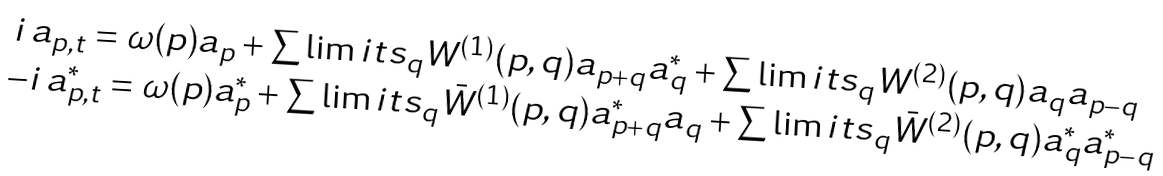<formula> <loc_0><loc_0><loc_500><loc_500>\begin{array} { l } \, i \, a _ { p , t } = \omega ( p ) a _ { p } + \sum \lim i t s _ { q } W ^ { ( 1 ) } ( p , q ) a _ { p + q } a _ { q } ^ { * } + \sum \lim i t s _ { q } W ^ { ( 2 ) } ( p , q ) a _ { q } a _ { p - q } \\ - i \, a ^ { * } _ { p , t } = \omega ( p ) a ^ { * } _ { p } + \sum \lim i t s _ { q } \bar { W } ^ { ( 1 ) } ( p , q ) a ^ { * } _ { p + q } a _ { q } + \sum \lim i t s _ { q } \bar { W } ^ { ( 2 ) } ( p , q ) a ^ { * } _ { q } a ^ { * } _ { p - q } \end{array}</formula> 